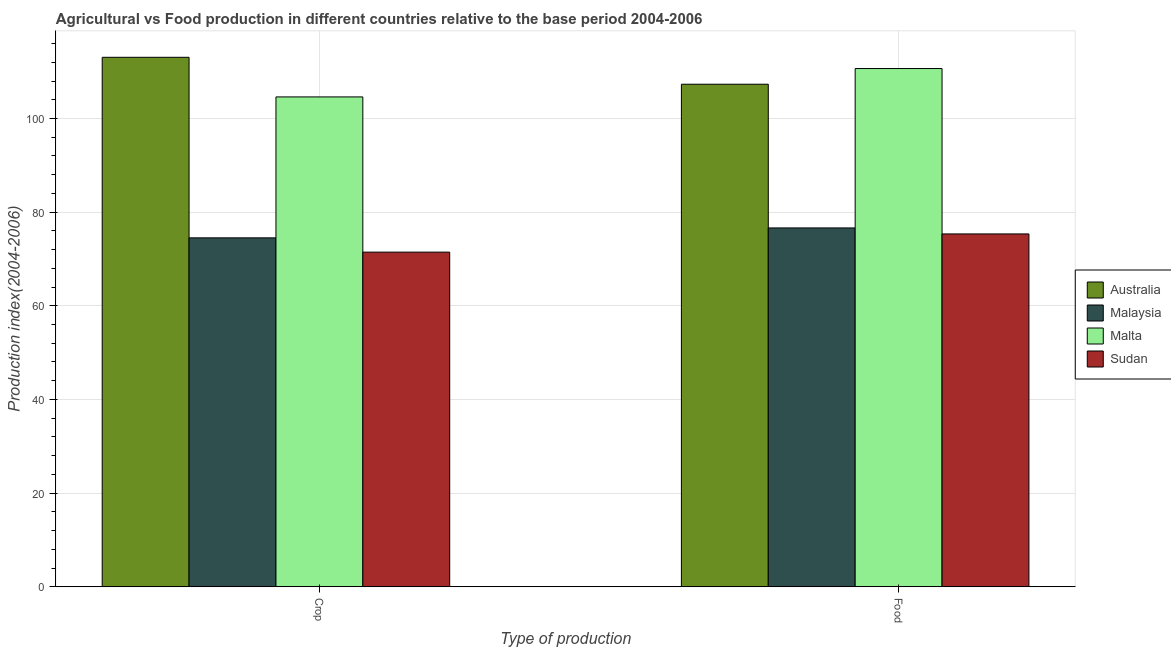Are the number of bars per tick equal to the number of legend labels?
Keep it short and to the point. Yes. What is the label of the 1st group of bars from the left?
Offer a terse response. Crop. What is the food production index in Malta?
Give a very brief answer. 110.67. Across all countries, what is the maximum food production index?
Give a very brief answer. 110.67. Across all countries, what is the minimum food production index?
Your response must be concise. 75.35. In which country was the crop production index maximum?
Keep it short and to the point. Australia. In which country was the crop production index minimum?
Offer a terse response. Sudan. What is the total crop production index in the graph?
Make the answer very short. 363.65. What is the difference between the food production index in Australia and that in Sudan?
Give a very brief answer. 31.97. What is the difference between the food production index in Malaysia and the crop production index in Australia?
Your answer should be compact. -36.44. What is the average food production index per country?
Make the answer very short. 92.49. What is the difference between the crop production index and food production index in Australia?
Your response must be concise. 5.75. What is the ratio of the food production index in Australia to that in Sudan?
Make the answer very short. 1.42. What does the 2nd bar from the left in Crop represents?
Your answer should be compact. Malaysia. What does the 2nd bar from the right in Food represents?
Offer a very short reply. Malta. How many bars are there?
Offer a terse response. 8. Are all the bars in the graph horizontal?
Offer a terse response. No. How many countries are there in the graph?
Your answer should be very brief. 4. Are the values on the major ticks of Y-axis written in scientific E-notation?
Keep it short and to the point. No. How many legend labels are there?
Offer a terse response. 4. How are the legend labels stacked?
Ensure brevity in your answer.  Vertical. What is the title of the graph?
Provide a short and direct response. Agricultural vs Food production in different countries relative to the base period 2004-2006. What is the label or title of the X-axis?
Keep it short and to the point. Type of production. What is the label or title of the Y-axis?
Make the answer very short. Production index(2004-2006). What is the Production index(2004-2006) in Australia in Crop?
Your answer should be compact. 113.07. What is the Production index(2004-2006) of Malaysia in Crop?
Your response must be concise. 74.51. What is the Production index(2004-2006) of Malta in Crop?
Offer a terse response. 104.61. What is the Production index(2004-2006) of Sudan in Crop?
Make the answer very short. 71.46. What is the Production index(2004-2006) in Australia in Food?
Your answer should be very brief. 107.32. What is the Production index(2004-2006) of Malaysia in Food?
Keep it short and to the point. 76.63. What is the Production index(2004-2006) of Malta in Food?
Your response must be concise. 110.67. What is the Production index(2004-2006) of Sudan in Food?
Your answer should be very brief. 75.35. Across all Type of production, what is the maximum Production index(2004-2006) in Australia?
Provide a short and direct response. 113.07. Across all Type of production, what is the maximum Production index(2004-2006) in Malaysia?
Give a very brief answer. 76.63. Across all Type of production, what is the maximum Production index(2004-2006) in Malta?
Make the answer very short. 110.67. Across all Type of production, what is the maximum Production index(2004-2006) in Sudan?
Provide a short and direct response. 75.35. Across all Type of production, what is the minimum Production index(2004-2006) of Australia?
Provide a succinct answer. 107.32. Across all Type of production, what is the minimum Production index(2004-2006) of Malaysia?
Offer a terse response. 74.51. Across all Type of production, what is the minimum Production index(2004-2006) in Malta?
Give a very brief answer. 104.61. Across all Type of production, what is the minimum Production index(2004-2006) in Sudan?
Keep it short and to the point. 71.46. What is the total Production index(2004-2006) of Australia in the graph?
Offer a terse response. 220.39. What is the total Production index(2004-2006) in Malaysia in the graph?
Your answer should be compact. 151.14. What is the total Production index(2004-2006) in Malta in the graph?
Give a very brief answer. 215.28. What is the total Production index(2004-2006) in Sudan in the graph?
Keep it short and to the point. 146.81. What is the difference between the Production index(2004-2006) of Australia in Crop and that in Food?
Provide a short and direct response. 5.75. What is the difference between the Production index(2004-2006) of Malaysia in Crop and that in Food?
Your answer should be compact. -2.12. What is the difference between the Production index(2004-2006) in Malta in Crop and that in Food?
Make the answer very short. -6.06. What is the difference between the Production index(2004-2006) of Sudan in Crop and that in Food?
Your answer should be compact. -3.89. What is the difference between the Production index(2004-2006) of Australia in Crop and the Production index(2004-2006) of Malaysia in Food?
Your answer should be very brief. 36.44. What is the difference between the Production index(2004-2006) of Australia in Crop and the Production index(2004-2006) of Malta in Food?
Give a very brief answer. 2.4. What is the difference between the Production index(2004-2006) in Australia in Crop and the Production index(2004-2006) in Sudan in Food?
Keep it short and to the point. 37.72. What is the difference between the Production index(2004-2006) of Malaysia in Crop and the Production index(2004-2006) of Malta in Food?
Provide a succinct answer. -36.16. What is the difference between the Production index(2004-2006) of Malaysia in Crop and the Production index(2004-2006) of Sudan in Food?
Ensure brevity in your answer.  -0.84. What is the difference between the Production index(2004-2006) in Malta in Crop and the Production index(2004-2006) in Sudan in Food?
Provide a succinct answer. 29.26. What is the average Production index(2004-2006) in Australia per Type of production?
Ensure brevity in your answer.  110.19. What is the average Production index(2004-2006) in Malaysia per Type of production?
Offer a very short reply. 75.57. What is the average Production index(2004-2006) in Malta per Type of production?
Ensure brevity in your answer.  107.64. What is the average Production index(2004-2006) of Sudan per Type of production?
Provide a succinct answer. 73.41. What is the difference between the Production index(2004-2006) in Australia and Production index(2004-2006) in Malaysia in Crop?
Ensure brevity in your answer.  38.56. What is the difference between the Production index(2004-2006) in Australia and Production index(2004-2006) in Malta in Crop?
Keep it short and to the point. 8.46. What is the difference between the Production index(2004-2006) in Australia and Production index(2004-2006) in Sudan in Crop?
Your answer should be very brief. 41.61. What is the difference between the Production index(2004-2006) of Malaysia and Production index(2004-2006) of Malta in Crop?
Make the answer very short. -30.1. What is the difference between the Production index(2004-2006) of Malaysia and Production index(2004-2006) of Sudan in Crop?
Ensure brevity in your answer.  3.05. What is the difference between the Production index(2004-2006) of Malta and Production index(2004-2006) of Sudan in Crop?
Your response must be concise. 33.15. What is the difference between the Production index(2004-2006) in Australia and Production index(2004-2006) in Malaysia in Food?
Provide a succinct answer. 30.69. What is the difference between the Production index(2004-2006) in Australia and Production index(2004-2006) in Malta in Food?
Offer a very short reply. -3.35. What is the difference between the Production index(2004-2006) in Australia and Production index(2004-2006) in Sudan in Food?
Offer a terse response. 31.97. What is the difference between the Production index(2004-2006) of Malaysia and Production index(2004-2006) of Malta in Food?
Your answer should be compact. -34.04. What is the difference between the Production index(2004-2006) of Malaysia and Production index(2004-2006) of Sudan in Food?
Your answer should be compact. 1.28. What is the difference between the Production index(2004-2006) of Malta and Production index(2004-2006) of Sudan in Food?
Provide a succinct answer. 35.32. What is the ratio of the Production index(2004-2006) of Australia in Crop to that in Food?
Keep it short and to the point. 1.05. What is the ratio of the Production index(2004-2006) of Malaysia in Crop to that in Food?
Your answer should be very brief. 0.97. What is the ratio of the Production index(2004-2006) in Malta in Crop to that in Food?
Give a very brief answer. 0.95. What is the ratio of the Production index(2004-2006) of Sudan in Crop to that in Food?
Provide a short and direct response. 0.95. What is the difference between the highest and the second highest Production index(2004-2006) of Australia?
Provide a succinct answer. 5.75. What is the difference between the highest and the second highest Production index(2004-2006) in Malaysia?
Your response must be concise. 2.12. What is the difference between the highest and the second highest Production index(2004-2006) in Malta?
Provide a short and direct response. 6.06. What is the difference between the highest and the second highest Production index(2004-2006) in Sudan?
Give a very brief answer. 3.89. What is the difference between the highest and the lowest Production index(2004-2006) in Australia?
Make the answer very short. 5.75. What is the difference between the highest and the lowest Production index(2004-2006) of Malaysia?
Your answer should be compact. 2.12. What is the difference between the highest and the lowest Production index(2004-2006) in Malta?
Offer a very short reply. 6.06. What is the difference between the highest and the lowest Production index(2004-2006) in Sudan?
Ensure brevity in your answer.  3.89. 